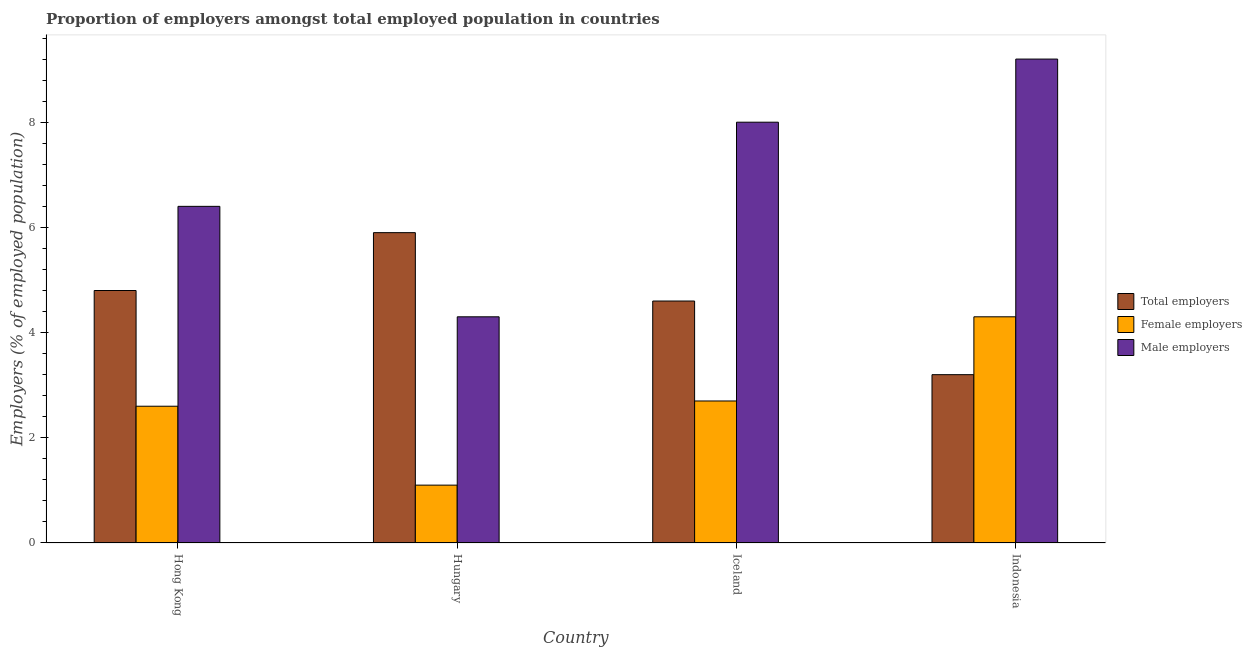Are the number of bars per tick equal to the number of legend labels?
Your response must be concise. Yes. How many bars are there on the 3rd tick from the left?
Your answer should be very brief. 3. What is the label of the 4th group of bars from the left?
Your answer should be very brief. Indonesia. What is the percentage of total employers in Indonesia?
Keep it short and to the point. 3.2. Across all countries, what is the maximum percentage of male employers?
Provide a short and direct response. 9.2. Across all countries, what is the minimum percentage of female employers?
Offer a very short reply. 1.1. What is the total percentage of male employers in the graph?
Provide a short and direct response. 27.9. What is the difference between the percentage of male employers in Hong Kong and that in Iceland?
Make the answer very short. -1.6. What is the difference between the percentage of male employers in Iceland and the percentage of total employers in Hong Kong?
Your answer should be compact. 3.2. What is the average percentage of total employers per country?
Your answer should be compact. 4.63. What is the difference between the percentage of female employers and percentage of total employers in Iceland?
Provide a short and direct response. -1.9. In how many countries, is the percentage of male employers greater than 4 %?
Your answer should be compact. 4. What is the ratio of the percentage of male employers in Hungary to that in Indonesia?
Your answer should be compact. 0.47. Is the percentage of total employers in Hong Kong less than that in Hungary?
Ensure brevity in your answer.  Yes. What is the difference between the highest and the second highest percentage of female employers?
Provide a short and direct response. 1.6. What is the difference between the highest and the lowest percentage of female employers?
Your response must be concise. 3.2. In how many countries, is the percentage of total employers greater than the average percentage of total employers taken over all countries?
Offer a terse response. 2. Is the sum of the percentage of male employers in Hong Kong and Indonesia greater than the maximum percentage of female employers across all countries?
Keep it short and to the point. Yes. What does the 3rd bar from the left in Hungary represents?
Ensure brevity in your answer.  Male employers. What does the 2nd bar from the right in Iceland represents?
Offer a terse response. Female employers. Is it the case that in every country, the sum of the percentage of total employers and percentage of female employers is greater than the percentage of male employers?
Your answer should be compact. No. Does the graph contain grids?
Make the answer very short. No. How are the legend labels stacked?
Your answer should be very brief. Vertical. What is the title of the graph?
Your answer should be very brief. Proportion of employers amongst total employed population in countries. Does "Ages 20-60" appear as one of the legend labels in the graph?
Ensure brevity in your answer.  No. What is the label or title of the Y-axis?
Provide a short and direct response. Employers (% of employed population). What is the Employers (% of employed population) in Total employers in Hong Kong?
Give a very brief answer. 4.8. What is the Employers (% of employed population) of Female employers in Hong Kong?
Give a very brief answer. 2.6. What is the Employers (% of employed population) in Male employers in Hong Kong?
Your answer should be compact. 6.4. What is the Employers (% of employed population) in Total employers in Hungary?
Your response must be concise. 5.9. What is the Employers (% of employed population) in Female employers in Hungary?
Provide a succinct answer. 1.1. What is the Employers (% of employed population) in Male employers in Hungary?
Offer a very short reply. 4.3. What is the Employers (% of employed population) in Total employers in Iceland?
Provide a short and direct response. 4.6. What is the Employers (% of employed population) of Female employers in Iceland?
Make the answer very short. 2.7. What is the Employers (% of employed population) in Male employers in Iceland?
Ensure brevity in your answer.  8. What is the Employers (% of employed population) of Total employers in Indonesia?
Keep it short and to the point. 3.2. What is the Employers (% of employed population) of Female employers in Indonesia?
Offer a terse response. 4.3. What is the Employers (% of employed population) of Male employers in Indonesia?
Offer a terse response. 9.2. Across all countries, what is the maximum Employers (% of employed population) of Total employers?
Make the answer very short. 5.9. Across all countries, what is the maximum Employers (% of employed population) of Female employers?
Your response must be concise. 4.3. Across all countries, what is the maximum Employers (% of employed population) of Male employers?
Offer a very short reply. 9.2. Across all countries, what is the minimum Employers (% of employed population) of Total employers?
Ensure brevity in your answer.  3.2. Across all countries, what is the minimum Employers (% of employed population) in Female employers?
Make the answer very short. 1.1. Across all countries, what is the minimum Employers (% of employed population) in Male employers?
Provide a succinct answer. 4.3. What is the total Employers (% of employed population) of Female employers in the graph?
Provide a succinct answer. 10.7. What is the total Employers (% of employed population) in Male employers in the graph?
Your answer should be very brief. 27.9. What is the difference between the Employers (% of employed population) of Female employers in Hong Kong and that in Hungary?
Give a very brief answer. 1.5. What is the difference between the Employers (% of employed population) of Total employers in Hong Kong and that in Indonesia?
Provide a short and direct response. 1.6. What is the difference between the Employers (% of employed population) in Male employers in Hong Kong and that in Indonesia?
Provide a succinct answer. -2.8. What is the difference between the Employers (% of employed population) of Total employers in Hungary and that in Iceland?
Keep it short and to the point. 1.3. What is the difference between the Employers (% of employed population) in Female employers in Hungary and that in Indonesia?
Give a very brief answer. -3.2. What is the difference between the Employers (% of employed population) of Total employers in Hong Kong and the Employers (% of employed population) of Female employers in Hungary?
Give a very brief answer. 3.7. What is the difference between the Employers (% of employed population) of Total employers in Hong Kong and the Employers (% of employed population) of Female employers in Iceland?
Your answer should be compact. 2.1. What is the difference between the Employers (% of employed population) in Total employers in Hong Kong and the Employers (% of employed population) in Male employers in Iceland?
Make the answer very short. -3.2. What is the difference between the Employers (% of employed population) in Female employers in Hong Kong and the Employers (% of employed population) in Male employers in Iceland?
Give a very brief answer. -5.4. What is the difference between the Employers (% of employed population) of Total employers in Hong Kong and the Employers (% of employed population) of Female employers in Indonesia?
Provide a succinct answer. 0.5. What is the difference between the Employers (% of employed population) in Total employers in Hong Kong and the Employers (% of employed population) in Male employers in Indonesia?
Provide a short and direct response. -4.4. What is the difference between the Employers (% of employed population) of Female employers in Hong Kong and the Employers (% of employed population) of Male employers in Indonesia?
Make the answer very short. -6.6. What is the difference between the Employers (% of employed population) of Total employers in Hungary and the Employers (% of employed population) of Female employers in Iceland?
Provide a short and direct response. 3.2. What is the difference between the Employers (% of employed population) in Total employers in Hungary and the Employers (% of employed population) in Female employers in Indonesia?
Provide a short and direct response. 1.6. What is the difference between the Employers (% of employed population) in Total employers in Iceland and the Employers (% of employed population) in Female employers in Indonesia?
Ensure brevity in your answer.  0.3. What is the average Employers (% of employed population) in Total employers per country?
Ensure brevity in your answer.  4.62. What is the average Employers (% of employed population) in Female employers per country?
Offer a very short reply. 2.67. What is the average Employers (% of employed population) of Male employers per country?
Provide a succinct answer. 6.97. What is the difference between the Employers (% of employed population) in Female employers and Employers (% of employed population) in Male employers in Hong Kong?
Your answer should be very brief. -3.8. What is the difference between the Employers (% of employed population) of Total employers and Employers (% of employed population) of Female employers in Iceland?
Keep it short and to the point. 1.9. What is the difference between the Employers (% of employed population) in Total employers and Employers (% of employed population) in Female employers in Indonesia?
Your response must be concise. -1.1. What is the difference between the Employers (% of employed population) in Total employers and Employers (% of employed population) in Male employers in Indonesia?
Your response must be concise. -6. What is the difference between the Employers (% of employed population) in Female employers and Employers (% of employed population) in Male employers in Indonesia?
Your answer should be very brief. -4.9. What is the ratio of the Employers (% of employed population) in Total employers in Hong Kong to that in Hungary?
Ensure brevity in your answer.  0.81. What is the ratio of the Employers (% of employed population) in Female employers in Hong Kong to that in Hungary?
Provide a short and direct response. 2.36. What is the ratio of the Employers (% of employed population) of Male employers in Hong Kong to that in Hungary?
Your answer should be compact. 1.49. What is the ratio of the Employers (% of employed population) in Total employers in Hong Kong to that in Iceland?
Give a very brief answer. 1.04. What is the ratio of the Employers (% of employed population) of Female employers in Hong Kong to that in Iceland?
Your answer should be compact. 0.96. What is the ratio of the Employers (% of employed population) in Male employers in Hong Kong to that in Iceland?
Your response must be concise. 0.8. What is the ratio of the Employers (% of employed population) of Total employers in Hong Kong to that in Indonesia?
Keep it short and to the point. 1.5. What is the ratio of the Employers (% of employed population) of Female employers in Hong Kong to that in Indonesia?
Offer a very short reply. 0.6. What is the ratio of the Employers (% of employed population) of Male employers in Hong Kong to that in Indonesia?
Your answer should be compact. 0.7. What is the ratio of the Employers (% of employed population) of Total employers in Hungary to that in Iceland?
Your response must be concise. 1.28. What is the ratio of the Employers (% of employed population) in Female employers in Hungary to that in Iceland?
Provide a succinct answer. 0.41. What is the ratio of the Employers (% of employed population) of Male employers in Hungary to that in Iceland?
Your answer should be compact. 0.54. What is the ratio of the Employers (% of employed population) in Total employers in Hungary to that in Indonesia?
Offer a terse response. 1.84. What is the ratio of the Employers (% of employed population) of Female employers in Hungary to that in Indonesia?
Your answer should be very brief. 0.26. What is the ratio of the Employers (% of employed population) in Male employers in Hungary to that in Indonesia?
Your answer should be compact. 0.47. What is the ratio of the Employers (% of employed population) in Total employers in Iceland to that in Indonesia?
Your response must be concise. 1.44. What is the ratio of the Employers (% of employed population) in Female employers in Iceland to that in Indonesia?
Your answer should be compact. 0.63. What is the ratio of the Employers (% of employed population) of Male employers in Iceland to that in Indonesia?
Offer a terse response. 0.87. What is the difference between the highest and the second highest Employers (% of employed population) in Total employers?
Make the answer very short. 1.1. What is the difference between the highest and the second highest Employers (% of employed population) in Male employers?
Keep it short and to the point. 1.2. What is the difference between the highest and the lowest Employers (% of employed population) of Female employers?
Provide a short and direct response. 3.2. What is the difference between the highest and the lowest Employers (% of employed population) in Male employers?
Provide a short and direct response. 4.9. 